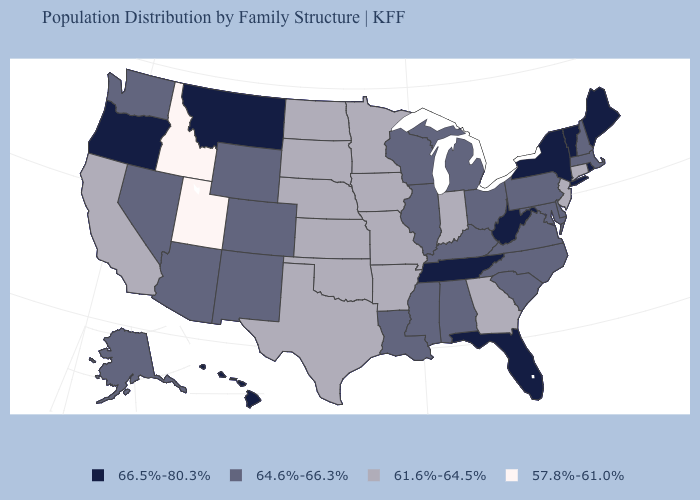Among the states that border Utah , does Colorado have the highest value?
Answer briefly. Yes. Among the states that border Pennsylvania , does Ohio have the lowest value?
Be succinct. No. Name the states that have a value in the range 66.5%-80.3%?
Concise answer only. Florida, Hawaii, Maine, Montana, New York, Oregon, Rhode Island, Tennessee, Vermont, West Virginia. Name the states that have a value in the range 57.8%-61.0%?
Quick response, please. Idaho, Utah. Does Utah have the lowest value in the USA?
Concise answer only. Yes. What is the value of Michigan?
Quick response, please. 64.6%-66.3%. What is the value of West Virginia?
Write a very short answer. 66.5%-80.3%. How many symbols are there in the legend?
Keep it brief. 4. Does Minnesota have a higher value than Utah?
Write a very short answer. Yes. What is the lowest value in states that border Indiana?
Write a very short answer. 64.6%-66.3%. Name the states that have a value in the range 61.6%-64.5%?
Short answer required. Arkansas, California, Connecticut, Georgia, Indiana, Iowa, Kansas, Minnesota, Missouri, Nebraska, New Jersey, North Dakota, Oklahoma, South Dakota, Texas. Which states have the highest value in the USA?
Short answer required. Florida, Hawaii, Maine, Montana, New York, Oregon, Rhode Island, Tennessee, Vermont, West Virginia. What is the lowest value in states that border West Virginia?
Concise answer only. 64.6%-66.3%. Does Wisconsin have the lowest value in the MidWest?
Write a very short answer. No. Which states have the highest value in the USA?
Answer briefly. Florida, Hawaii, Maine, Montana, New York, Oregon, Rhode Island, Tennessee, Vermont, West Virginia. 